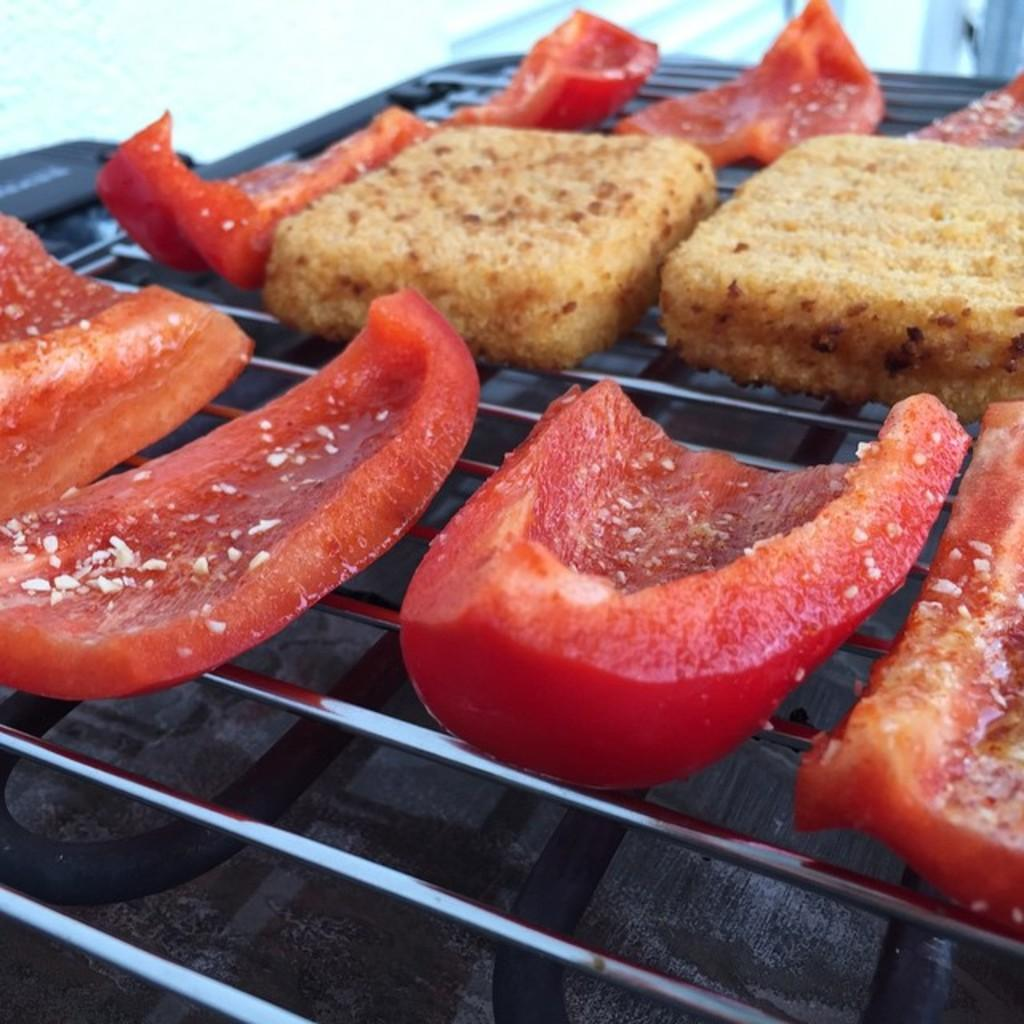What type of food is present on the barbecue table in the image? There are cookies and tomato pieces on the barbecue table. What song is being sung by the tomato pieces on the barbecue table? There is no song being sung by the tomato pieces on the barbecue table, as they are inanimate objects and cannot sing. 